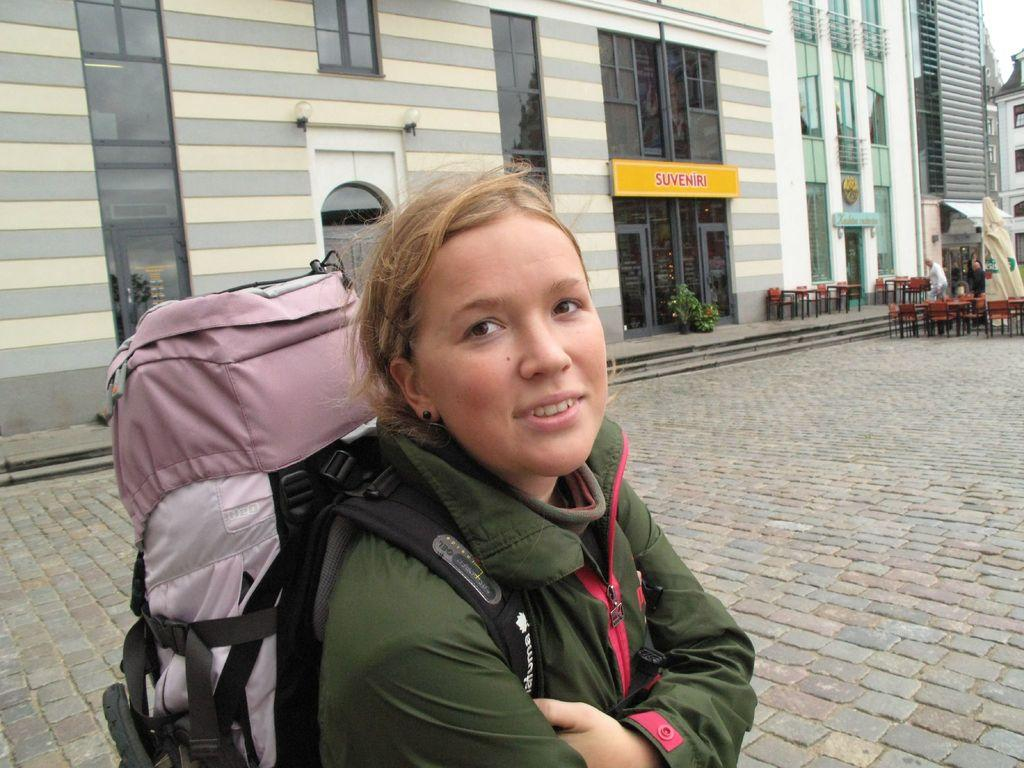<image>
Give a short and clear explanation of the subsequent image. Girl with a tall backpack on her stnading in front of Suvveniri. 